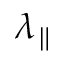Convert formula to latex. <formula><loc_0><loc_0><loc_500><loc_500>\lambda _ { \| }</formula> 